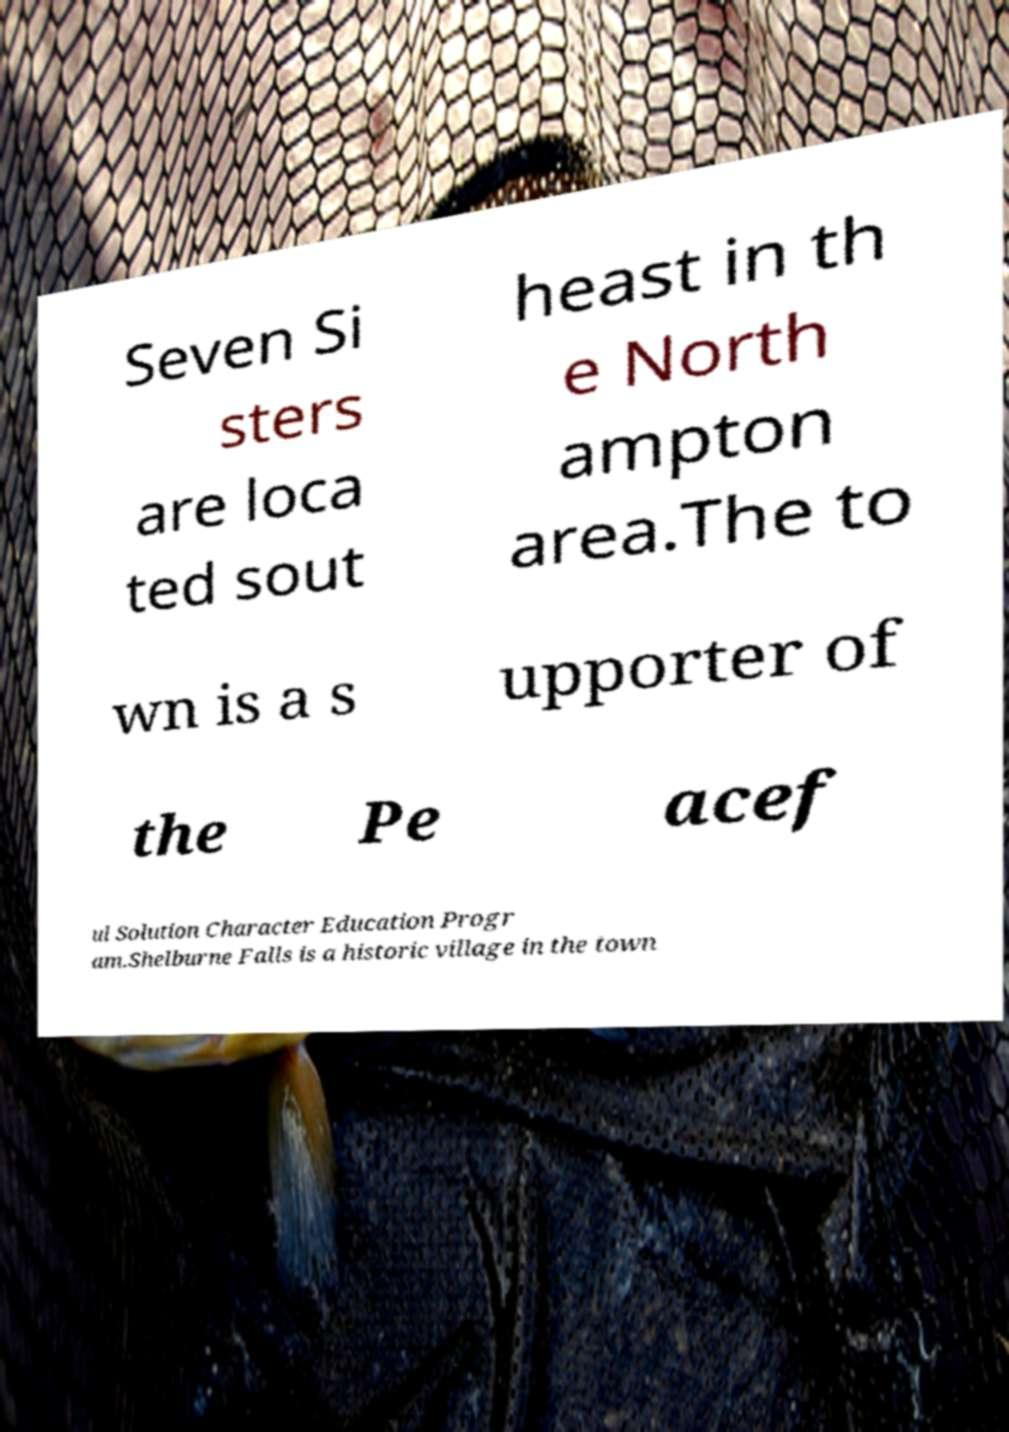Please identify and transcribe the text found in this image. Seven Si sters are loca ted sout heast in th e North ampton area.The to wn is a s upporter of the Pe acef ul Solution Character Education Progr am.Shelburne Falls is a historic village in the town 